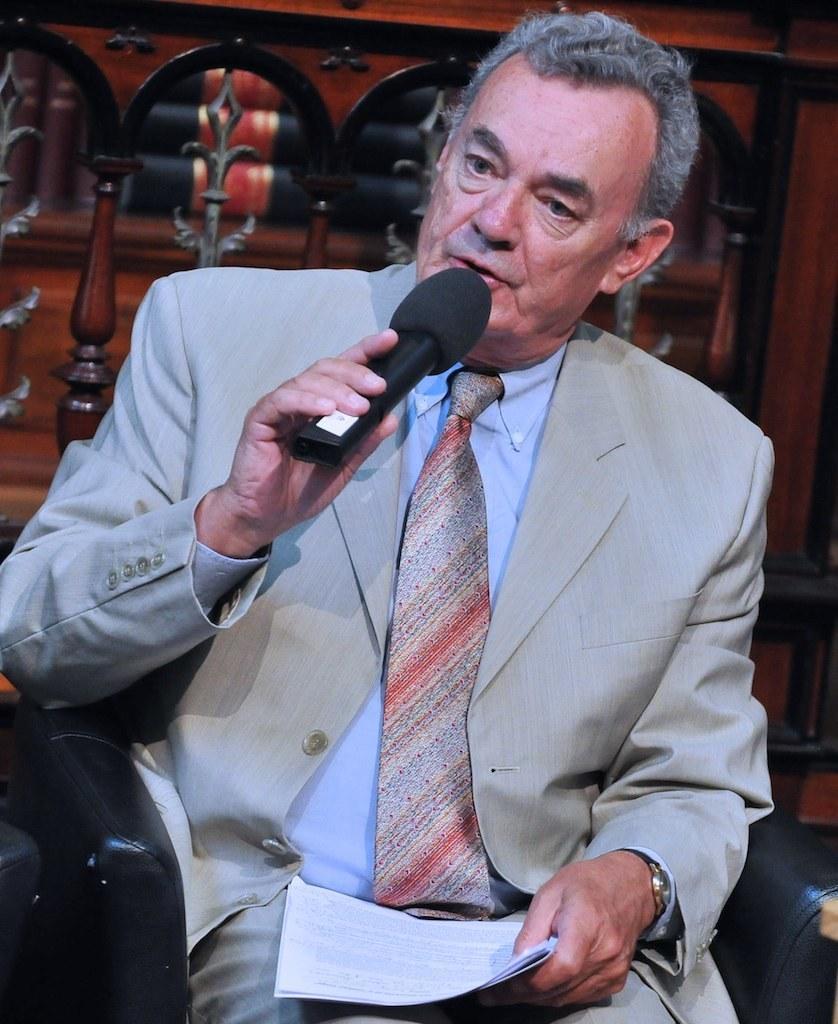How would you summarize this image in a sentence or two? man sitting on the sofa,holding mike,wearing watch,holding paper. 